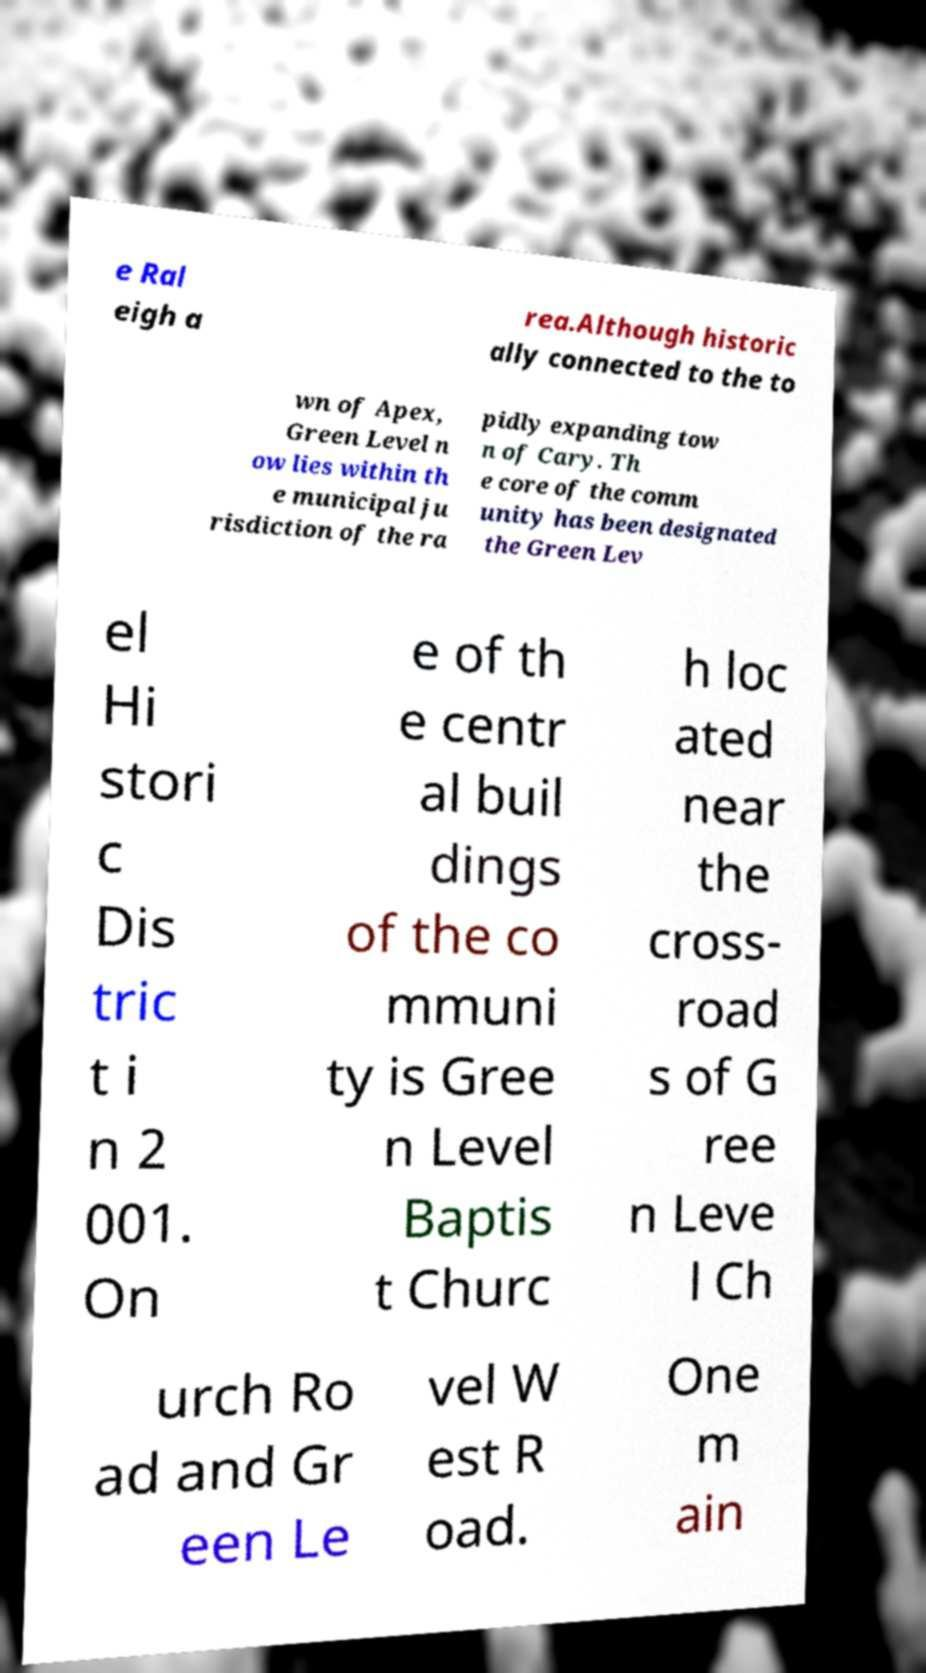Can you read and provide the text displayed in the image?This photo seems to have some interesting text. Can you extract and type it out for me? e Ral eigh a rea.Although historic ally connected to the to wn of Apex, Green Level n ow lies within th e municipal ju risdiction of the ra pidly expanding tow n of Cary. Th e core of the comm unity has been designated the Green Lev el Hi stori c Dis tric t i n 2 001. On e of th e centr al buil dings of the co mmuni ty is Gree n Level Baptis t Churc h loc ated near the cross- road s of G ree n Leve l Ch urch Ro ad and Gr een Le vel W est R oad. One m ain 